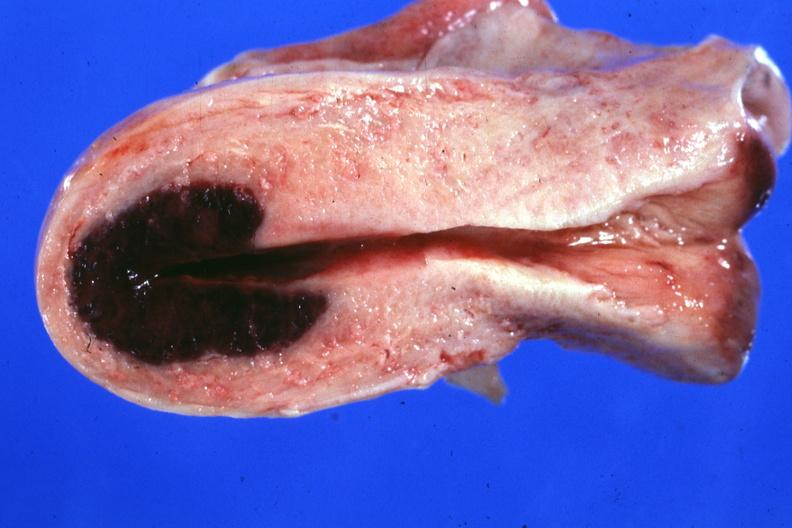what does this image show?
Answer the question using a single word or phrase. Localized lesion in dome of uterus said to have adenosis adenomyosis hemorrhage probably due to shock 